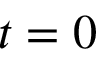Convert formula to latex. <formula><loc_0><loc_0><loc_500><loc_500>t = 0</formula> 